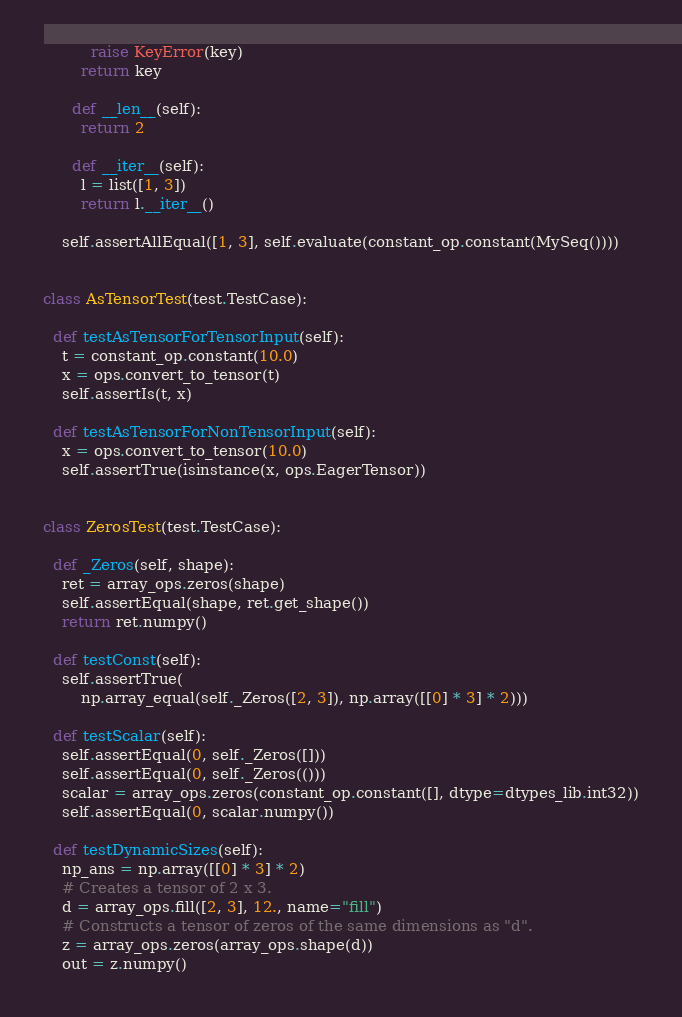<code> <loc_0><loc_0><loc_500><loc_500><_Python_>          raise KeyError(key)
        return key

      def __len__(self):
        return 2

      def __iter__(self):
        l = list([1, 3])
        return l.__iter__()

    self.assertAllEqual([1, 3], self.evaluate(constant_op.constant(MySeq())))


class AsTensorTest(test.TestCase):

  def testAsTensorForTensorInput(self):
    t = constant_op.constant(10.0)
    x = ops.convert_to_tensor(t)
    self.assertIs(t, x)

  def testAsTensorForNonTensorInput(self):
    x = ops.convert_to_tensor(10.0)
    self.assertTrue(isinstance(x, ops.EagerTensor))


class ZerosTest(test.TestCase):

  def _Zeros(self, shape):
    ret = array_ops.zeros(shape)
    self.assertEqual(shape, ret.get_shape())
    return ret.numpy()

  def testConst(self):
    self.assertTrue(
        np.array_equal(self._Zeros([2, 3]), np.array([[0] * 3] * 2)))

  def testScalar(self):
    self.assertEqual(0, self._Zeros([]))
    self.assertEqual(0, self._Zeros(()))
    scalar = array_ops.zeros(constant_op.constant([], dtype=dtypes_lib.int32))
    self.assertEqual(0, scalar.numpy())

  def testDynamicSizes(self):
    np_ans = np.array([[0] * 3] * 2)
    # Creates a tensor of 2 x 3.
    d = array_ops.fill([2, 3], 12., name="fill")
    # Constructs a tensor of zeros of the same dimensions as "d".
    z = array_ops.zeros(array_ops.shape(d))
    out = z.numpy()</code> 